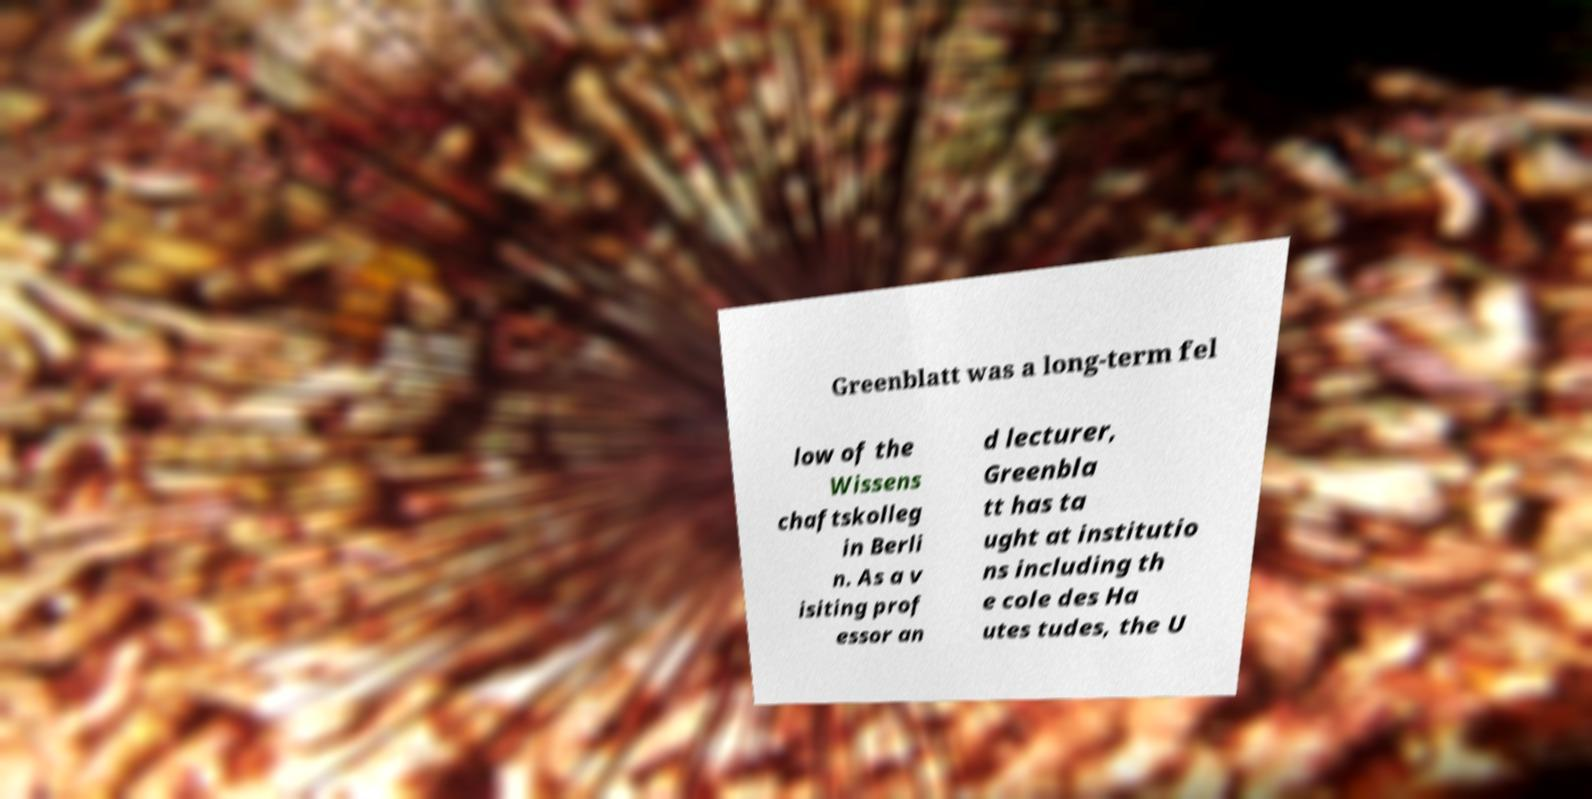I need the written content from this picture converted into text. Can you do that? Greenblatt was a long-term fel low of the Wissens chaftskolleg in Berli n. As a v isiting prof essor an d lecturer, Greenbla tt has ta ught at institutio ns including th e cole des Ha utes tudes, the U 